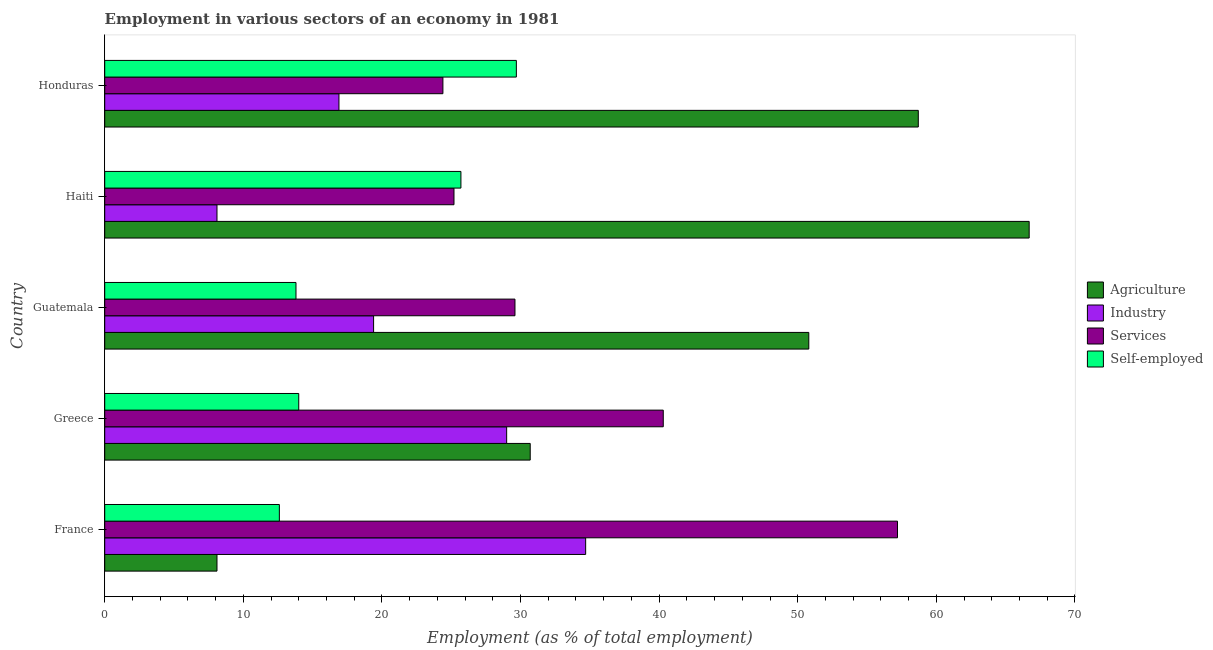How many different coloured bars are there?
Offer a terse response. 4. How many groups of bars are there?
Your answer should be very brief. 5. Are the number of bars on each tick of the Y-axis equal?
Ensure brevity in your answer.  Yes. How many bars are there on the 2nd tick from the top?
Offer a terse response. 4. What is the label of the 3rd group of bars from the top?
Offer a terse response. Guatemala. What is the percentage of workers in industry in Haiti?
Offer a terse response. 8.1. Across all countries, what is the maximum percentage of self employed workers?
Give a very brief answer. 29.7. Across all countries, what is the minimum percentage of self employed workers?
Offer a terse response. 12.6. In which country was the percentage of workers in agriculture maximum?
Offer a very short reply. Haiti. What is the total percentage of workers in services in the graph?
Your response must be concise. 176.7. What is the difference between the percentage of workers in industry in France and that in Haiti?
Provide a short and direct response. 26.6. What is the difference between the percentage of workers in services in Guatemala and the percentage of workers in industry in Haiti?
Give a very brief answer. 21.5. What is the average percentage of workers in industry per country?
Offer a terse response. 21.62. What is the difference between the percentage of workers in agriculture and percentage of self employed workers in Haiti?
Ensure brevity in your answer.  41. In how many countries, is the percentage of self employed workers greater than 30 %?
Provide a succinct answer. 0. What is the ratio of the percentage of workers in services in France to that in Greece?
Your answer should be compact. 1.42. What is the difference between the highest and the second highest percentage of workers in services?
Provide a short and direct response. 16.9. What is the difference between the highest and the lowest percentage of workers in industry?
Provide a short and direct response. 26.6. Is the sum of the percentage of workers in industry in Guatemala and Honduras greater than the maximum percentage of workers in agriculture across all countries?
Give a very brief answer. No. What does the 3rd bar from the top in Guatemala represents?
Your answer should be compact. Industry. What does the 4th bar from the bottom in Haiti represents?
Make the answer very short. Self-employed. How many bars are there?
Make the answer very short. 20. How many countries are there in the graph?
Your answer should be very brief. 5. What is the difference between two consecutive major ticks on the X-axis?
Make the answer very short. 10. Are the values on the major ticks of X-axis written in scientific E-notation?
Keep it short and to the point. No. Does the graph contain grids?
Keep it short and to the point. No. Where does the legend appear in the graph?
Provide a succinct answer. Center right. How are the legend labels stacked?
Ensure brevity in your answer.  Vertical. What is the title of the graph?
Your answer should be compact. Employment in various sectors of an economy in 1981. Does "Sweden" appear as one of the legend labels in the graph?
Provide a short and direct response. No. What is the label or title of the X-axis?
Your answer should be compact. Employment (as % of total employment). What is the Employment (as % of total employment) of Agriculture in France?
Give a very brief answer. 8.1. What is the Employment (as % of total employment) of Industry in France?
Keep it short and to the point. 34.7. What is the Employment (as % of total employment) of Services in France?
Offer a terse response. 57.2. What is the Employment (as % of total employment) of Self-employed in France?
Make the answer very short. 12.6. What is the Employment (as % of total employment) in Agriculture in Greece?
Offer a terse response. 30.7. What is the Employment (as % of total employment) of Industry in Greece?
Ensure brevity in your answer.  29. What is the Employment (as % of total employment) of Services in Greece?
Your answer should be compact. 40.3. What is the Employment (as % of total employment) of Self-employed in Greece?
Your answer should be very brief. 14. What is the Employment (as % of total employment) of Agriculture in Guatemala?
Ensure brevity in your answer.  50.8. What is the Employment (as % of total employment) of Industry in Guatemala?
Make the answer very short. 19.4. What is the Employment (as % of total employment) in Services in Guatemala?
Ensure brevity in your answer.  29.6. What is the Employment (as % of total employment) of Self-employed in Guatemala?
Provide a succinct answer. 13.8. What is the Employment (as % of total employment) of Agriculture in Haiti?
Your answer should be very brief. 66.7. What is the Employment (as % of total employment) of Industry in Haiti?
Keep it short and to the point. 8.1. What is the Employment (as % of total employment) in Services in Haiti?
Offer a terse response. 25.2. What is the Employment (as % of total employment) in Self-employed in Haiti?
Ensure brevity in your answer.  25.7. What is the Employment (as % of total employment) of Agriculture in Honduras?
Make the answer very short. 58.7. What is the Employment (as % of total employment) of Industry in Honduras?
Your answer should be very brief. 16.9. What is the Employment (as % of total employment) in Services in Honduras?
Your answer should be compact. 24.4. What is the Employment (as % of total employment) in Self-employed in Honduras?
Ensure brevity in your answer.  29.7. Across all countries, what is the maximum Employment (as % of total employment) in Agriculture?
Keep it short and to the point. 66.7. Across all countries, what is the maximum Employment (as % of total employment) of Industry?
Your answer should be compact. 34.7. Across all countries, what is the maximum Employment (as % of total employment) in Services?
Keep it short and to the point. 57.2. Across all countries, what is the maximum Employment (as % of total employment) in Self-employed?
Offer a terse response. 29.7. Across all countries, what is the minimum Employment (as % of total employment) in Agriculture?
Your response must be concise. 8.1. Across all countries, what is the minimum Employment (as % of total employment) in Industry?
Offer a very short reply. 8.1. Across all countries, what is the minimum Employment (as % of total employment) of Services?
Offer a very short reply. 24.4. Across all countries, what is the minimum Employment (as % of total employment) in Self-employed?
Provide a succinct answer. 12.6. What is the total Employment (as % of total employment) of Agriculture in the graph?
Give a very brief answer. 215. What is the total Employment (as % of total employment) of Industry in the graph?
Provide a succinct answer. 108.1. What is the total Employment (as % of total employment) in Services in the graph?
Your answer should be compact. 176.7. What is the total Employment (as % of total employment) in Self-employed in the graph?
Ensure brevity in your answer.  95.8. What is the difference between the Employment (as % of total employment) of Agriculture in France and that in Greece?
Your response must be concise. -22.6. What is the difference between the Employment (as % of total employment) of Industry in France and that in Greece?
Make the answer very short. 5.7. What is the difference between the Employment (as % of total employment) in Self-employed in France and that in Greece?
Provide a short and direct response. -1.4. What is the difference between the Employment (as % of total employment) of Agriculture in France and that in Guatemala?
Offer a very short reply. -42.7. What is the difference between the Employment (as % of total employment) in Industry in France and that in Guatemala?
Offer a terse response. 15.3. What is the difference between the Employment (as % of total employment) in Services in France and that in Guatemala?
Give a very brief answer. 27.6. What is the difference between the Employment (as % of total employment) in Self-employed in France and that in Guatemala?
Provide a short and direct response. -1.2. What is the difference between the Employment (as % of total employment) of Agriculture in France and that in Haiti?
Give a very brief answer. -58.6. What is the difference between the Employment (as % of total employment) of Industry in France and that in Haiti?
Offer a very short reply. 26.6. What is the difference between the Employment (as % of total employment) of Services in France and that in Haiti?
Provide a succinct answer. 32. What is the difference between the Employment (as % of total employment) in Self-employed in France and that in Haiti?
Your response must be concise. -13.1. What is the difference between the Employment (as % of total employment) in Agriculture in France and that in Honduras?
Offer a very short reply. -50.6. What is the difference between the Employment (as % of total employment) in Industry in France and that in Honduras?
Provide a succinct answer. 17.8. What is the difference between the Employment (as % of total employment) of Services in France and that in Honduras?
Your answer should be compact. 32.8. What is the difference between the Employment (as % of total employment) of Self-employed in France and that in Honduras?
Make the answer very short. -17.1. What is the difference between the Employment (as % of total employment) of Agriculture in Greece and that in Guatemala?
Your answer should be very brief. -20.1. What is the difference between the Employment (as % of total employment) in Agriculture in Greece and that in Haiti?
Your answer should be very brief. -36. What is the difference between the Employment (as % of total employment) in Industry in Greece and that in Haiti?
Give a very brief answer. 20.9. What is the difference between the Employment (as % of total employment) of Self-employed in Greece and that in Haiti?
Keep it short and to the point. -11.7. What is the difference between the Employment (as % of total employment) of Services in Greece and that in Honduras?
Provide a short and direct response. 15.9. What is the difference between the Employment (as % of total employment) of Self-employed in Greece and that in Honduras?
Give a very brief answer. -15.7. What is the difference between the Employment (as % of total employment) in Agriculture in Guatemala and that in Haiti?
Provide a short and direct response. -15.9. What is the difference between the Employment (as % of total employment) of Industry in Guatemala and that in Haiti?
Offer a very short reply. 11.3. What is the difference between the Employment (as % of total employment) in Agriculture in Guatemala and that in Honduras?
Provide a succinct answer. -7.9. What is the difference between the Employment (as % of total employment) in Industry in Guatemala and that in Honduras?
Offer a very short reply. 2.5. What is the difference between the Employment (as % of total employment) of Self-employed in Guatemala and that in Honduras?
Ensure brevity in your answer.  -15.9. What is the difference between the Employment (as % of total employment) in Self-employed in Haiti and that in Honduras?
Provide a short and direct response. -4. What is the difference between the Employment (as % of total employment) of Agriculture in France and the Employment (as % of total employment) of Industry in Greece?
Ensure brevity in your answer.  -20.9. What is the difference between the Employment (as % of total employment) of Agriculture in France and the Employment (as % of total employment) of Services in Greece?
Your answer should be compact. -32.2. What is the difference between the Employment (as % of total employment) in Industry in France and the Employment (as % of total employment) in Services in Greece?
Offer a very short reply. -5.6. What is the difference between the Employment (as % of total employment) of Industry in France and the Employment (as % of total employment) of Self-employed in Greece?
Keep it short and to the point. 20.7. What is the difference between the Employment (as % of total employment) of Services in France and the Employment (as % of total employment) of Self-employed in Greece?
Give a very brief answer. 43.2. What is the difference between the Employment (as % of total employment) of Agriculture in France and the Employment (as % of total employment) of Services in Guatemala?
Your response must be concise. -21.5. What is the difference between the Employment (as % of total employment) of Agriculture in France and the Employment (as % of total employment) of Self-employed in Guatemala?
Provide a short and direct response. -5.7. What is the difference between the Employment (as % of total employment) in Industry in France and the Employment (as % of total employment) in Services in Guatemala?
Your answer should be very brief. 5.1. What is the difference between the Employment (as % of total employment) in Industry in France and the Employment (as % of total employment) in Self-employed in Guatemala?
Offer a very short reply. 20.9. What is the difference between the Employment (as % of total employment) of Services in France and the Employment (as % of total employment) of Self-employed in Guatemala?
Ensure brevity in your answer.  43.4. What is the difference between the Employment (as % of total employment) of Agriculture in France and the Employment (as % of total employment) of Services in Haiti?
Offer a terse response. -17.1. What is the difference between the Employment (as % of total employment) in Agriculture in France and the Employment (as % of total employment) in Self-employed in Haiti?
Your response must be concise. -17.6. What is the difference between the Employment (as % of total employment) of Services in France and the Employment (as % of total employment) of Self-employed in Haiti?
Provide a succinct answer. 31.5. What is the difference between the Employment (as % of total employment) of Agriculture in France and the Employment (as % of total employment) of Services in Honduras?
Make the answer very short. -16.3. What is the difference between the Employment (as % of total employment) in Agriculture in France and the Employment (as % of total employment) in Self-employed in Honduras?
Provide a succinct answer. -21.6. What is the difference between the Employment (as % of total employment) in Services in France and the Employment (as % of total employment) in Self-employed in Honduras?
Make the answer very short. 27.5. What is the difference between the Employment (as % of total employment) of Agriculture in Greece and the Employment (as % of total employment) of Self-employed in Guatemala?
Your answer should be very brief. 16.9. What is the difference between the Employment (as % of total employment) in Industry in Greece and the Employment (as % of total employment) in Services in Guatemala?
Your answer should be very brief. -0.6. What is the difference between the Employment (as % of total employment) in Agriculture in Greece and the Employment (as % of total employment) in Industry in Haiti?
Your answer should be compact. 22.6. What is the difference between the Employment (as % of total employment) of Industry in Greece and the Employment (as % of total employment) of Services in Haiti?
Ensure brevity in your answer.  3.8. What is the difference between the Employment (as % of total employment) in Industry in Greece and the Employment (as % of total employment) in Self-employed in Haiti?
Your response must be concise. 3.3. What is the difference between the Employment (as % of total employment) of Services in Greece and the Employment (as % of total employment) of Self-employed in Haiti?
Keep it short and to the point. 14.6. What is the difference between the Employment (as % of total employment) of Agriculture in Greece and the Employment (as % of total employment) of Industry in Honduras?
Your answer should be compact. 13.8. What is the difference between the Employment (as % of total employment) of Agriculture in Greece and the Employment (as % of total employment) of Services in Honduras?
Ensure brevity in your answer.  6.3. What is the difference between the Employment (as % of total employment) of Industry in Greece and the Employment (as % of total employment) of Self-employed in Honduras?
Ensure brevity in your answer.  -0.7. What is the difference between the Employment (as % of total employment) in Agriculture in Guatemala and the Employment (as % of total employment) in Industry in Haiti?
Provide a short and direct response. 42.7. What is the difference between the Employment (as % of total employment) of Agriculture in Guatemala and the Employment (as % of total employment) of Services in Haiti?
Your response must be concise. 25.6. What is the difference between the Employment (as % of total employment) of Agriculture in Guatemala and the Employment (as % of total employment) of Self-employed in Haiti?
Your answer should be compact. 25.1. What is the difference between the Employment (as % of total employment) of Industry in Guatemala and the Employment (as % of total employment) of Services in Haiti?
Provide a succinct answer. -5.8. What is the difference between the Employment (as % of total employment) of Industry in Guatemala and the Employment (as % of total employment) of Self-employed in Haiti?
Provide a short and direct response. -6.3. What is the difference between the Employment (as % of total employment) of Agriculture in Guatemala and the Employment (as % of total employment) of Industry in Honduras?
Offer a terse response. 33.9. What is the difference between the Employment (as % of total employment) of Agriculture in Guatemala and the Employment (as % of total employment) of Services in Honduras?
Your response must be concise. 26.4. What is the difference between the Employment (as % of total employment) of Agriculture in Guatemala and the Employment (as % of total employment) of Self-employed in Honduras?
Provide a succinct answer. 21.1. What is the difference between the Employment (as % of total employment) in Industry in Guatemala and the Employment (as % of total employment) in Self-employed in Honduras?
Your answer should be very brief. -10.3. What is the difference between the Employment (as % of total employment) of Services in Guatemala and the Employment (as % of total employment) of Self-employed in Honduras?
Your answer should be compact. -0.1. What is the difference between the Employment (as % of total employment) of Agriculture in Haiti and the Employment (as % of total employment) of Industry in Honduras?
Make the answer very short. 49.8. What is the difference between the Employment (as % of total employment) of Agriculture in Haiti and the Employment (as % of total employment) of Services in Honduras?
Your answer should be compact. 42.3. What is the difference between the Employment (as % of total employment) of Industry in Haiti and the Employment (as % of total employment) of Services in Honduras?
Ensure brevity in your answer.  -16.3. What is the difference between the Employment (as % of total employment) in Industry in Haiti and the Employment (as % of total employment) in Self-employed in Honduras?
Keep it short and to the point. -21.6. What is the average Employment (as % of total employment) in Agriculture per country?
Your answer should be compact. 43. What is the average Employment (as % of total employment) in Industry per country?
Your answer should be compact. 21.62. What is the average Employment (as % of total employment) in Services per country?
Ensure brevity in your answer.  35.34. What is the average Employment (as % of total employment) in Self-employed per country?
Ensure brevity in your answer.  19.16. What is the difference between the Employment (as % of total employment) of Agriculture and Employment (as % of total employment) of Industry in France?
Your answer should be very brief. -26.6. What is the difference between the Employment (as % of total employment) in Agriculture and Employment (as % of total employment) in Services in France?
Give a very brief answer. -49.1. What is the difference between the Employment (as % of total employment) of Agriculture and Employment (as % of total employment) of Self-employed in France?
Provide a succinct answer. -4.5. What is the difference between the Employment (as % of total employment) in Industry and Employment (as % of total employment) in Services in France?
Keep it short and to the point. -22.5. What is the difference between the Employment (as % of total employment) of Industry and Employment (as % of total employment) of Self-employed in France?
Give a very brief answer. 22.1. What is the difference between the Employment (as % of total employment) in Services and Employment (as % of total employment) in Self-employed in France?
Give a very brief answer. 44.6. What is the difference between the Employment (as % of total employment) of Agriculture and Employment (as % of total employment) of Industry in Greece?
Offer a terse response. 1.7. What is the difference between the Employment (as % of total employment) in Agriculture and Employment (as % of total employment) in Services in Greece?
Make the answer very short. -9.6. What is the difference between the Employment (as % of total employment) in Agriculture and Employment (as % of total employment) in Self-employed in Greece?
Offer a very short reply. 16.7. What is the difference between the Employment (as % of total employment) in Industry and Employment (as % of total employment) in Self-employed in Greece?
Offer a terse response. 15. What is the difference between the Employment (as % of total employment) in Services and Employment (as % of total employment) in Self-employed in Greece?
Your response must be concise. 26.3. What is the difference between the Employment (as % of total employment) in Agriculture and Employment (as % of total employment) in Industry in Guatemala?
Your response must be concise. 31.4. What is the difference between the Employment (as % of total employment) of Agriculture and Employment (as % of total employment) of Services in Guatemala?
Your response must be concise. 21.2. What is the difference between the Employment (as % of total employment) in Industry and Employment (as % of total employment) in Services in Guatemala?
Your response must be concise. -10.2. What is the difference between the Employment (as % of total employment) of Industry and Employment (as % of total employment) of Self-employed in Guatemala?
Ensure brevity in your answer.  5.6. What is the difference between the Employment (as % of total employment) in Agriculture and Employment (as % of total employment) in Industry in Haiti?
Offer a terse response. 58.6. What is the difference between the Employment (as % of total employment) of Agriculture and Employment (as % of total employment) of Services in Haiti?
Keep it short and to the point. 41.5. What is the difference between the Employment (as % of total employment) of Industry and Employment (as % of total employment) of Services in Haiti?
Your response must be concise. -17.1. What is the difference between the Employment (as % of total employment) of Industry and Employment (as % of total employment) of Self-employed in Haiti?
Your answer should be very brief. -17.6. What is the difference between the Employment (as % of total employment) in Services and Employment (as % of total employment) in Self-employed in Haiti?
Provide a short and direct response. -0.5. What is the difference between the Employment (as % of total employment) of Agriculture and Employment (as % of total employment) of Industry in Honduras?
Ensure brevity in your answer.  41.8. What is the difference between the Employment (as % of total employment) of Agriculture and Employment (as % of total employment) of Services in Honduras?
Offer a very short reply. 34.3. What is the difference between the Employment (as % of total employment) of Agriculture and Employment (as % of total employment) of Self-employed in Honduras?
Offer a very short reply. 29. What is the difference between the Employment (as % of total employment) of Industry and Employment (as % of total employment) of Services in Honduras?
Your response must be concise. -7.5. What is the difference between the Employment (as % of total employment) in Industry and Employment (as % of total employment) in Self-employed in Honduras?
Offer a very short reply. -12.8. What is the ratio of the Employment (as % of total employment) of Agriculture in France to that in Greece?
Your answer should be very brief. 0.26. What is the ratio of the Employment (as % of total employment) in Industry in France to that in Greece?
Your answer should be compact. 1.2. What is the ratio of the Employment (as % of total employment) in Services in France to that in Greece?
Ensure brevity in your answer.  1.42. What is the ratio of the Employment (as % of total employment) of Agriculture in France to that in Guatemala?
Your response must be concise. 0.16. What is the ratio of the Employment (as % of total employment) of Industry in France to that in Guatemala?
Your answer should be compact. 1.79. What is the ratio of the Employment (as % of total employment) in Services in France to that in Guatemala?
Make the answer very short. 1.93. What is the ratio of the Employment (as % of total employment) in Agriculture in France to that in Haiti?
Provide a succinct answer. 0.12. What is the ratio of the Employment (as % of total employment) of Industry in France to that in Haiti?
Ensure brevity in your answer.  4.28. What is the ratio of the Employment (as % of total employment) in Services in France to that in Haiti?
Provide a short and direct response. 2.27. What is the ratio of the Employment (as % of total employment) of Self-employed in France to that in Haiti?
Offer a very short reply. 0.49. What is the ratio of the Employment (as % of total employment) of Agriculture in France to that in Honduras?
Ensure brevity in your answer.  0.14. What is the ratio of the Employment (as % of total employment) of Industry in France to that in Honduras?
Keep it short and to the point. 2.05. What is the ratio of the Employment (as % of total employment) in Services in France to that in Honduras?
Your answer should be very brief. 2.34. What is the ratio of the Employment (as % of total employment) of Self-employed in France to that in Honduras?
Your answer should be compact. 0.42. What is the ratio of the Employment (as % of total employment) in Agriculture in Greece to that in Guatemala?
Give a very brief answer. 0.6. What is the ratio of the Employment (as % of total employment) in Industry in Greece to that in Guatemala?
Ensure brevity in your answer.  1.49. What is the ratio of the Employment (as % of total employment) of Services in Greece to that in Guatemala?
Make the answer very short. 1.36. What is the ratio of the Employment (as % of total employment) of Self-employed in Greece to that in Guatemala?
Offer a terse response. 1.01. What is the ratio of the Employment (as % of total employment) in Agriculture in Greece to that in Haiti?
Provide a succinct answer. 0.46. What is the ratio of the Employment (as % of total employment) in Industry in Greece to that in Haiti?
Provide a short and direct response. 3.58. What is the ratio of the Employment (as % of total employment) of Services in Greece to that in Haiti?
Provide a short and direct response. 1.6. What is the ratio of the Employment (as % of total employment) in Self-employed in Greece to that in Haiti?
Provide a succinct answer. 0.54. What is the ratio of the Employment (as % of total employment) in Agriculture in Greece to that in Honduras?
Offer a terse response. 0.52. What is the ratio of the Employment (as % of total employment) in Industry in Greece to that in Honduras?
Provide a succinct answer. 1.72. What is the ratio of the Employment (as % of total employment) in Services in Greece to that in Honduras?
Give a very brief answer. 1.65. What is the ratio of the Employment (as % of total employment) in Self-employed in Greece to that in Honduras?
Provide a succinct answer. 0.47. What is the ratio of the Employment (as % of total employment) in Agriculture in Guatemala to that in Haiti?
Give a very brief answer. 0.76. What is the ratio of the Employment (as % of total employment) in Industry in Guatemala to that in Haiti?
Make the answer very short. 2.4. What is the ratio of the Employment (as % of total employment) of Services in Guatemala to that in Haiti?
Ensure brevity in your answer.  1.17. What is the ratio of the Employment (as % of total employment) in Self-employed in Guatemala to that in Haiti?
Give a very brief answer. 0.54. What is the ratio of the Employment (as % of total employment) in Agriculture in Guatemala to that in Honduras?
Offer a very short reply. 0.87. What is the ratio of the Employment (as % of total employment) of Industry in Guatemala to that in Honduras?
Your answer should be very brief. 1.15. What is the ratio of the Employment (as % of total employment) in Services in Guatemala to that in Honduras?
Keep it short and to the point. 1.21. What is the ratio of the Employment (as % of total employment) of Self-employed in Guatemala to that in Honduras?
Your answer should be very brief. 0.46. What is the ratio of the Employment (as % of total employment) in Agriculture in Haiti to that in Honduras?
Give a very brief answer. 1.14. What is the ratio of the Employment (as % of total employment) of Industry in Haiti to that in Honduras?
Give a very brief answer. 0.48. What is the ratio of the Employment (as % of total employment) of Services in Haiti to that in Honduras?
Keep it short and to the point. 1.03. What is the ratio of the Employment (as % of total employment) of Self-employed in Haiti to that in Honduras?
Offer a very short reply. 0.87. What is the difference between the highest and the second highest Employment (as % of total employment) in Services?
Offer a terse response. 16.9. What is the difference between the highest and the second highest Employment (as % of total employment) of Self-employed?
Keep it short and to the point. 4. What is the difference between the highest and the lowest Employment (as % of total employment) of Agriculture?
Ensure brevity in your answer.  58.6. What is the difference between the highest and the lowest Employment (as % of total employment) of Industry?
Provide a short and direct response. 26.6. What is the difference between the highest and the lowest Employment (as % of total employment) of Services?
Your response must be concise. 32.8. What is the difference between the highest and the lowest Employment (as % of total employment) in Self-employed?
Ensure brevity in your answer.  17.1. 